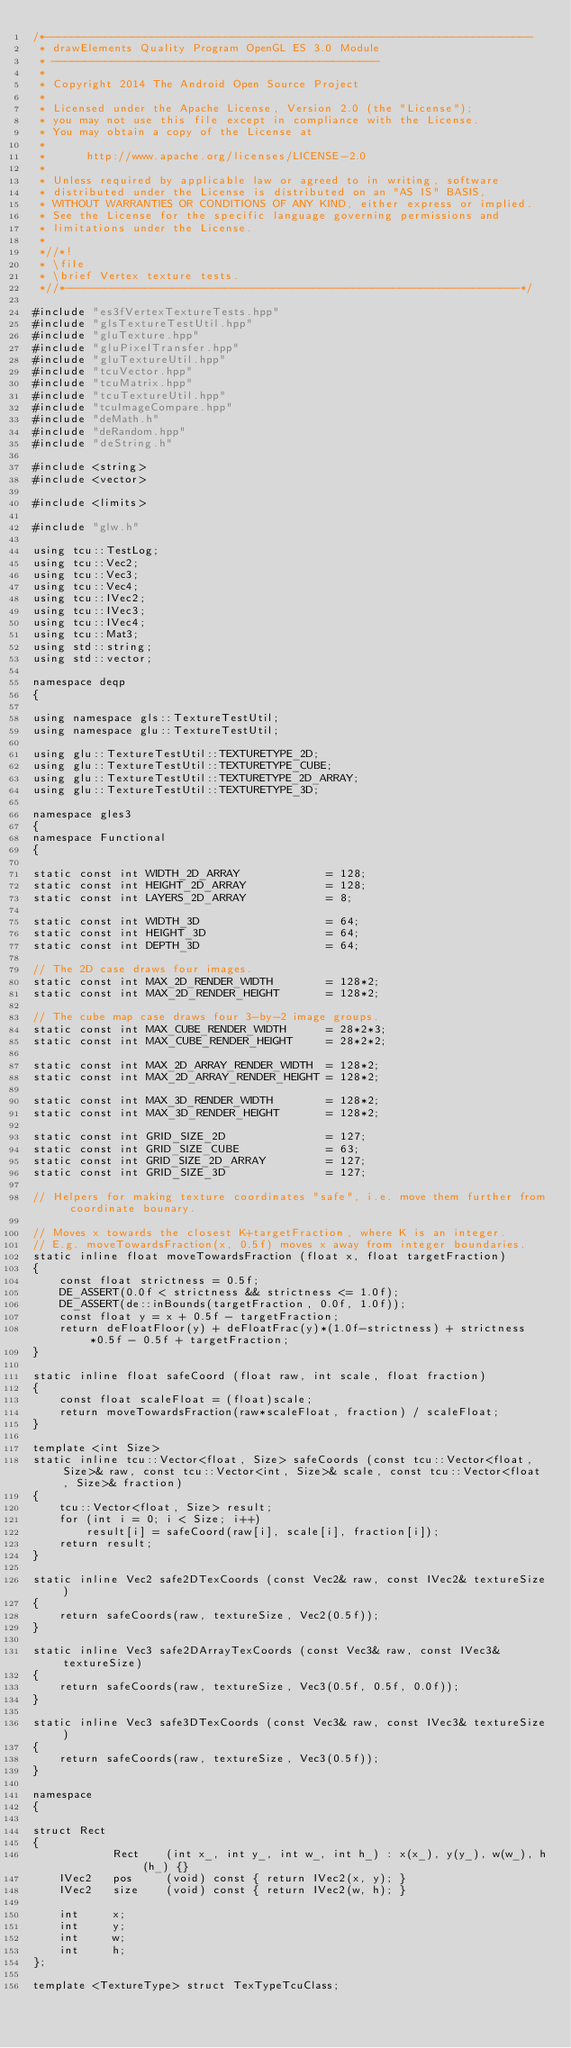<code> <loc_0><loc_0><loc_500><loc_500><_C++_>/*-------------------------------------------------------------------------
 * drawElements Quality Program OpenGL ES 3.0 Module
 * -------------------------------------------------
 *
 * Copyright 2014 The Android Open Source Project
 *
 * Licensed under the Apache License, Version 2.0 (the "License");
 * you may not use this file except in compliance with the License.
 * You may obtain a copy of the License at
 *
 *      http://www.apache.org/licenses/LICENSE-2.0
 *
 * Unless required by applicable law or agreed to in writing, software
 * distributed under the License is distributed on an "AS IS" BASIS,
 * WITHOUT WARRANTIES OR CONDITIONS OF ANY KIND, either express or implied.
 * See the License for the specific language governing permissions and
 * limitations under the License.
 *
 *//*!
 * \file
 * \brief Vertex texture tests.
 *//*--------------------------------------------------------------------*/

#include "es3fVertexTextureTests.hpp"
#include "glsTextureTestUtil.hpp"
#include "gluTexture.hpp"
#include "gluPixelTransfer.hpp"
#include "gluTextureUtil.hpp"
#include "tcuVector.hpp"
#include "tcuMatrix.hpp"
#include "tcuTextureUtil.hpp"
#include "tcuImageCompare.hpp"
#include "deMath.h"
#include "deRandom.hpp"
#include "deString.h"

#include <string>
#include <vector>

#include <limits>

#include "glw.h"

using tcu::TestLog;
using tcu::Vec2;
using tcu::Vec3;
using tcu::Vec4;
using tcu::IVec2;
using tcu::IVec3;
using tcu::IVec4;
using tcu::Mat3;
using std::string;
using std::vector;

namespace deqp
{

using namespace gls::TextureTestUtil;
using namespace glu::TextureTestUtil;

using glu::TextureTestUtil::TEXTURETYPE_2D;
using glu::TextureTestUtil::TEXTURETYPE_CUBE;
using glu::TextureTestUtil::TEXTURETYPE_2D_ARRAY;
using glu::TextureTestUtil::TEXTURETYPE_3D;

namespace gles3
{
namespace Functional
{

static const int WIDTH_2D_ARRAY				= 128;
static const int HEIGHT_2D_ARRAY			= 128;
static const int LAYERS_2D_ARRAY			= 8;

static const int WIDTH_3D					= 64;
static const int HEIGHT_3D					= 64;
static const int DEPTH_3D					= 64;

// The 2D case draws four images.
static const int MAX_2D_RENDER_WIDTH		= 128*2;
static const int MAX_2D_RENDER_HEIGHT		= 128*2;

// The cube map case draws four 3-by-2 image groups.
static const int MAX_CUBE_RENDER_WIDTH		= 28*2*3;
static const int MAX_CUBE_RENDER_HEIGHT		= 28*2*2;

static const int MAX_2D_ARRAY_RENDER_WIDTH	= 128*2;
static const int MAX_2D_ARRAY_RENDER_HEIGHT	= 128*2;

static const int MAX_3D_RENDER_WIDTH		= 128*2;
static const int MAX_3D_RENDER_HEIGHT		= 128*2;

static const int GRID_SIZE_2D				= 127;
static const int GRID_SIZE_CUBE				= 63;
static const int GRID_SIZE_2D_ARRAY			= 127;
static const int GRID_SIZE_3D				= 127;

// Helpers for making texture coordinates "safe", i.e. move them further from coordinate bounary.

// Moves x towards the closest K+targetFraction, where K is an integer.
// E.g. moveTowardsFraction(x, 0.5f) moves x away from integer boundaries.
static inline float moveTowardsFraction (float x, float targetFraction)
{
	const float strictness = 0.5f;
	DE_ASSERT(0.0f < strictness && strictness <= 1.0f);
	DE_ASSERT(de::inBounds(targetFraction, 0.0f, 1.0f));
	const float y = x + 0.5f - targetFraction;
	return deFloatFloor(y) + deFloatFrac(y)*(1.0f-strictness) + strictness*0.5f - 0.5f + targetFraction;
}

static inline float safeCoord (float raw, int scale, float fraction)
{
	const float scaleFloat = (float)scale;
	return moveTowardsFraction(raw*scaleFloat, fraction) / scaleFloat;
}

template <int Size>
static inline tcu::Vector<float, Size> safeCoords (const tcu::Vector<float, Size>& raw, const tcu::Vector<int, Size>& scale, const tcu::Vector<float, Size>& fraction)
{
	tcu::Vector<float, Size> result;
	for (int i = 0; i < Size; i++)
		result[i] = safeCoord(raw[i], scale[i], fraction[i]);
	return result;
}

static inline Vec2 safe2DTexCoords (const Vec2& raw, const IVec2& textureSize)
{
	return safeCoords(raw, textureSize, Vec2(0.5f));
}

static inline Vec3 safe2DArrayTexCoords (const Vec3& raw, const IVec3& textureSize)
{
	return safeCoords(raw, textureSize, Vec3(0.5f, 0.5f, 0.0f));
}

static inline Vec3 safe3DTexCoords (const Vec3& raw, const IVec3& textureSize)
{
	return safeCoords(raw, textureSize, Vec3(0.5f));
}

namespace
{

struct Rect
{
			Rect	(int x_, int y_, int w_, int h_) : x(x_), y(y_), w(w_), h(h_) {}
	IVec2	pos		(void) const { return IVec2(x, y); }
	IVec2	size	(void) const { return IVec2(w, h); }

	int		x;
	int		y;
	int		w;
	int		h;
};

template <TextureType> struct TexTypeTcuClass;</code> 